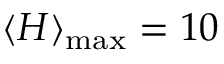Convert formula to latex. <formula><loc_0><loc_0><loc_500><loc_500>\langle H \rangle _ { \max } = 1 0</formula> 